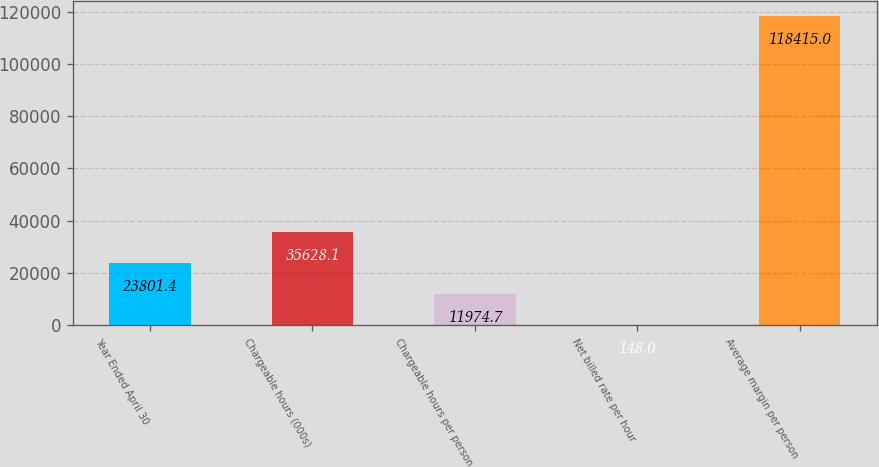Convert chart. <chart><loc_0><loc_0><loc_500><loc_500><bar_chart><fcel>Year Ended April 30<fcel>Chargeable hours (000s)<fcel>Chargeable hours per person<fcel>Net billed rate per hour<fcel>Average margin per person<nl><fcel>23801.4<fcel>35628.1<fcel>11974.7<fcel>148<fcel>118415<nl></chart> 